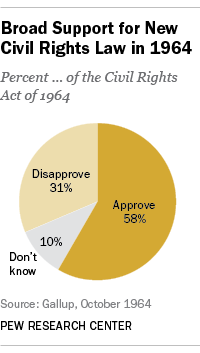Outline some significant characteristics in this image. There are three segments. The percentage of people supporting a new civil rights law exceeds the percentage of those not supporting it by 27%. 